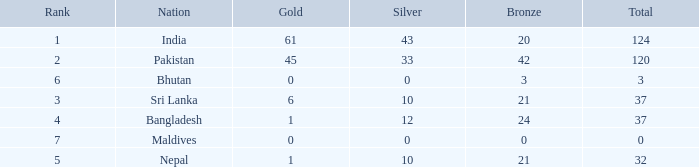Help me parse the entirety of this table. {'header': ['Rank', 'Nation', 'Gold', 'Silver', 'Bronze', 'Total'], 'rows': [['1', 'India', '61', '43', '20', '124'], ['2', 'Pakistan', '45', '33', '42', '120'], ['6', 'Bhutan', '0', '0', '3', '3'], ['3', 'Sri Lanka', '6', '10', '21', '37'], ['4', 'Bangladesh', '1', '12', '24', '37'], ['7', 'Maldives', '0', '0', '0', '0'], ['5', 'Nepal', '1', '10', '21', '32']]} How much Silver has a Rank of 7? 1.0. 